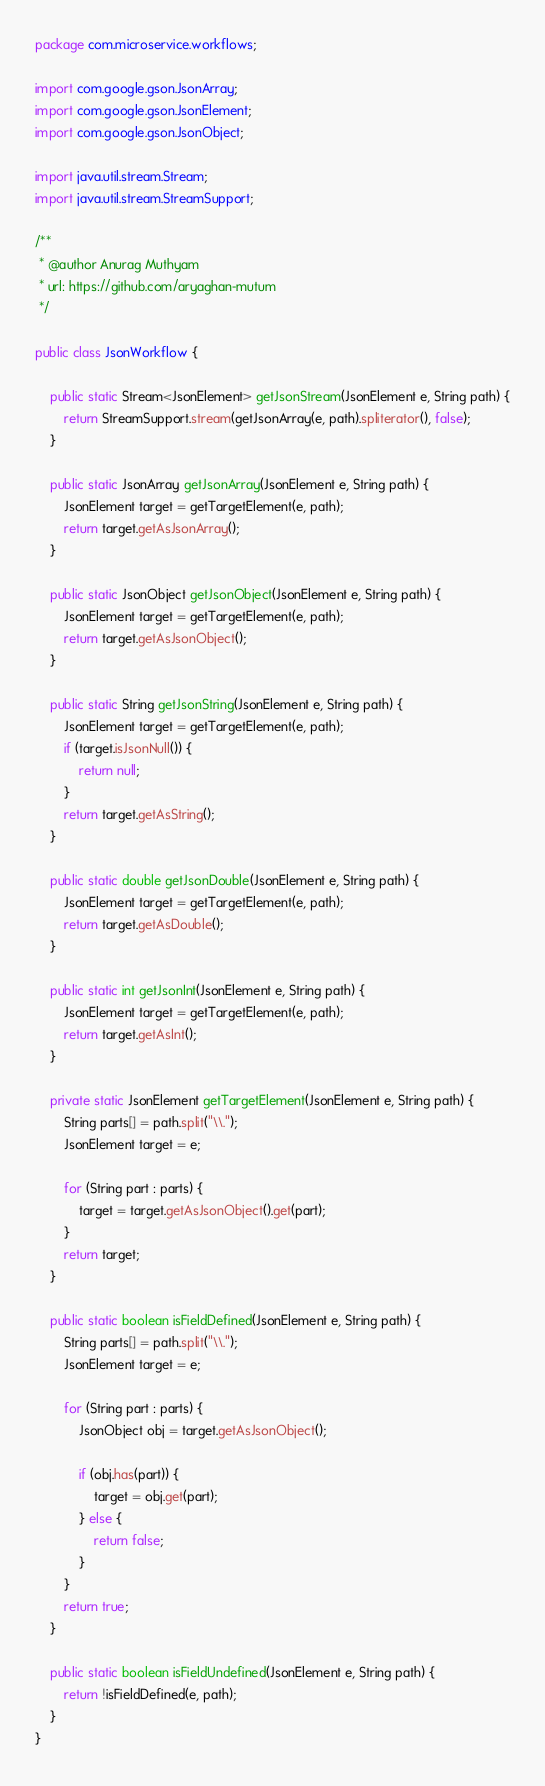Convert code to text. <code><loc_0><loc_0><loc_500><loc_500><_Java_>package com.microservice.workflows;

import com.google.gson.JsonArray;
import com.google.gson.JsonElement;
import com.google.gson.JsonObject;

import java.util.stream.Stream;
import java.util.stream.StreamSupport;

/**
 * @author Anurag Muthyam
 * url: https://github.com/aryaghan-mutum
 */

public class JsonWorkflow {

    public static Stream<JsonElement> getJsonStream(JsonElement e, String path) {
        return StreamSupport.stream(getJsonArray(e, path).spliterator(), false);
    }

    public static JsonArray getJsonArray(JsonElement e, String path) {
        JsonElement target = getTargetElement(e, path);
        return target.getAsJsonArray();
    }

    public static JsonObject getJsonObject(JsonElement e, String path) {
        JsonElement target = getTargetElement(e, path);
        return target.getAsJsonObject();
    }

    public static String getJsonString(JsonElement e, String path) {
        JsonElement target = getTargetElement(e, path);
        if (target.isJsonNull()) {
            return null;
        }
        return target.getAsString();
    }

    public static double getJsonDouble(JsonElement e, String path) {
        JsonElement target = getTargetElement(e, path);
        return target.getAsDouble();
    }

    public static int getJsonInt(JsonElement e, String path) {
        JsonElement target = getTargetElement(e, path);
        return target.getAsInt();
    }

    private static JsonElement getTargetElement(JsonElement e, String path) {
        String parts[] = path.split("\\.");
        JsonElement target = e;

        for (String part : parts) {
            target = target.getAsJsonObject().get(part);
        }
        return target;
    }

    public static boolean isFieldDefined(JsonElement e, String path) {
        String parts[] = path.split("\\.");
        JsonElement target = e;

        for (String part : parts) {
            JsonObject obj = target.getAsJsonObject();

            if (obj.has(part)) {
                target = obj.get(part);
            } else {
                return false;
            }
        }
        return true;
    }

    public static boolean isFieldUndefined(JsonElement e, String path) {
        return !isFieldDefined(e, path);
    }
}
</code> 